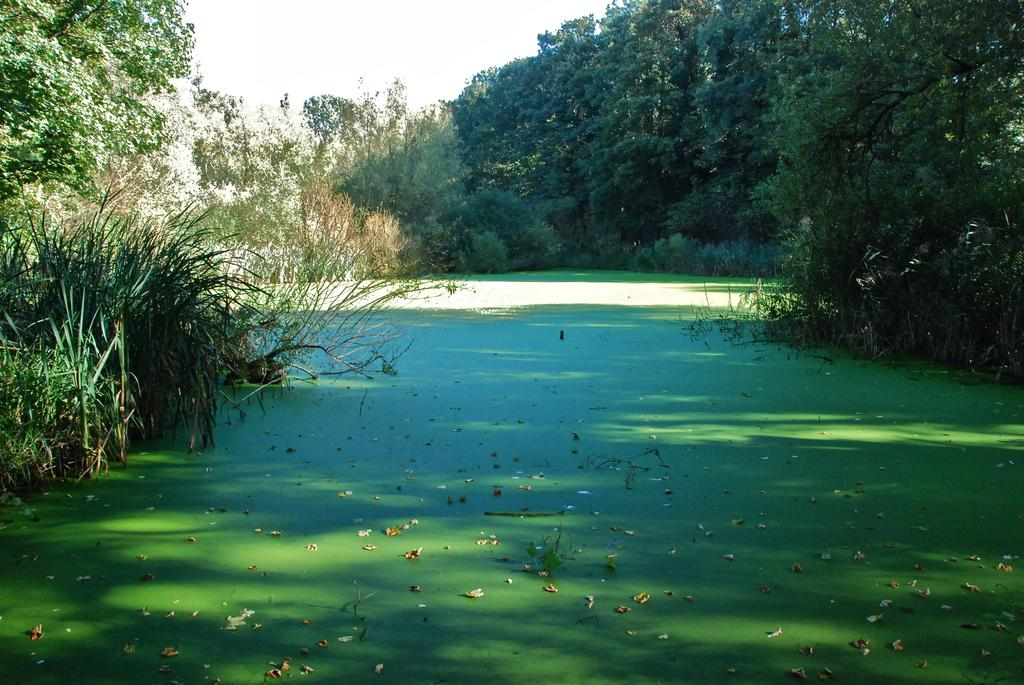What is visible in the image? There is water visible in the image. What is located around the water? There is a group of plants and trees around the water. What can be seen in the sky in the image? The sky is visible at the top of the image. What is floating on the water? There are leaves on the water. Where is the flock of pears located in the image? There is no flock of pears present in the image. What theory is being discussed in the image? There is no discussion or theory present in the image. 